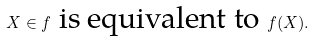Convert formula to latex. <formula><loc_0><loc_0><loc_500><loc_500>X \in f \text { is equivalent to } f ( X ) .</formula> 